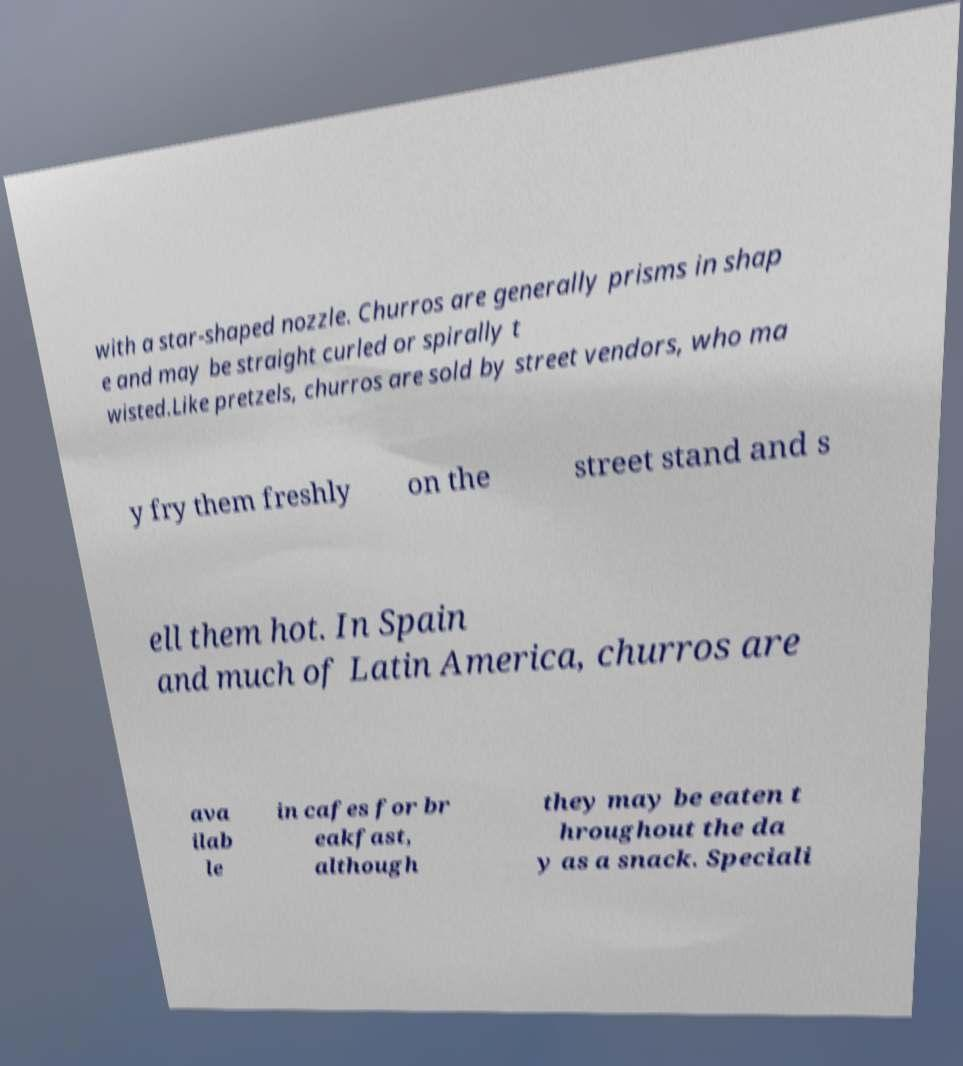There's text embedded in this image that I need extracted. Can you transcribe it verbatim? with a star-shaped nozzle. Churros are generally prisms in shap e and may be straight curled or spirally t wisted.Like pretzels, churros are sold by street vendors, who ma y fry them freshly on the street stand and s ell them hot. In Spain and much of Latin America, churros are ava ilab le in cafes for br eakfast, although they may be eaten t hroughout the da y as a snack. Speciali 